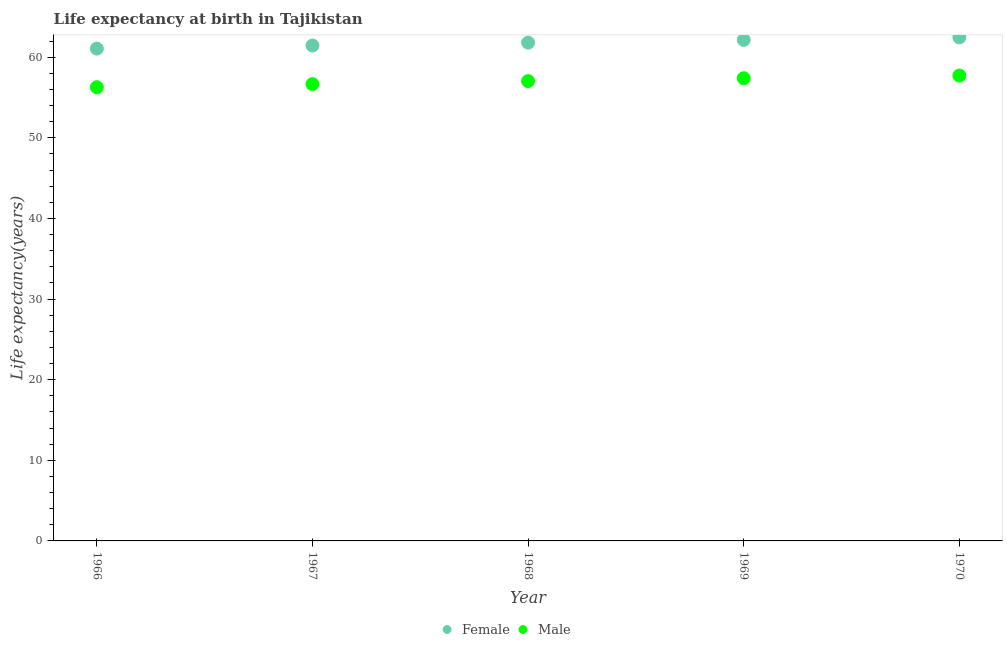Is the number of dotlines equal to the number of legend labels?
Your answer should be very brief. Yes. What is the life expectancy(male) in 1968?
Offer a terse response. 57.03. Across all years, what is the maximum life expectancy(female)?
Offer a very short reply. 62.46. Across all years, what is the minimum life expectancy(female)?
Your answer should be compact. 61.06. In which year was the life expectancy(male) minimum?
Your answer should be very brief. 1966. What is the total life expectancy(female) in the graph?
Provide a succinct answer. 308.91. What is the difference between the life expectancy(female) in 1966 and that in 1968?
Give a very brief answer. -0.74. What is the difference between the life expectancy(male) in 1969 and the life expectancy(female) in 1967?
Ensure brevity in your answer.  -4.05. What is the average life expectancy(female) per year?
Your answer should be very brief. 61.78. In the year 1968, what is the difference between the life expectancy(male) and life expectancy(female)?
Your answer should be very brief. -4.77. What is the ratio of the life expectancy(male) in 1968 to that in 1969?
Your response must be concise. 0.99. What is the difference between the highest and the second highest life expectancy(male)?
Your response must be concise. 0.33. What is the difference between the highest and the lowest life expectancy(male)?
Keep it short and to the point. 1.45. Does the graph contain grids?
Provide a short and direct response. No. How many legend labels are there?
Ensure brevity in your answer.  2. What is the title of the graph?
Ensure brevity in your answer.  Life expectancy at birth in Tajikistan. What is the label or title of the Y-axis?
Your answer should be compact. Life expectancy(years). What is the Life expectancy(years) in Female in 1966?
Your answer should be very brief. 61.06. What is the Life expectancy(years) of Male in 1966?
Your response must be concise. 56.27. What is the Life expectancy(years) of Female in 1967?
Your answer should be very brief. 61.44. What is the Life expectancy(years) in Male in 1967?
Make the answer very short. 56.66. What is the Life expectancy(years) of Female in 1968?
Offer a very short reply. 61.8. What is the Life expectancy(years) in Male in 1968?
Provide a short and direct response. 57.03. What is the Life expectancy(years) of Female in 1969?
Provide a succinct answer. 62.14. What is the Life expectancy(years) in Male in 1969?
Provide a short and direct response. 57.39. What is the Life expectancy(years) in Female in 1970?
Offer a very short reply. 62.46. What is the Life expectancy(years) of Male in 1970?
Keep it short and to the point. 57.72. Across all years, what is the maximum Life expectancy(years) of Female?
Provide a succinct answer. 62.46. Across all years, what is the maximum Life expectancy(years) of Male?
Provide a succinct answer. 57.72. Across all years, what is the minimum Life expectancy(years) of Female?
Provide a short and direct response. 61.06. Across all years, what is the minimum Life expectancy(years) in Male?
Give a very brief answer. 56.27. What is the total Life expectancy(years) in Female in the graph?
Provide a succinct answer. 308.91. What is the total Life expectancy(years) of Male in the graph?
Keep it short and to the point. 285.07. What is the difference between the Life expectancy(years) in Female in 1966 and that in 1967?
Make the answer very short. -0.38. What is the difference between the Life expectancy(years) in Male in 1966 and that in 1967?
Your response must be concise. -0.39. What is the difference between the Life expectancy(years) of Female in 1966 and that in 1968?
Your answer should be compact. -0.74. What is the difference between the Life expectancy(years) of Male in 1966 and that in 1968?
Keep it short and to the point. -0.76. What is the difference between the Life expectancy(years) of Female in 1966 and that in 1969?
Your response must be concise. -1.08. What is the difference between the Life expectancy(years) in Male in 1966 and that in 1969?
Your answer should be compact. -1.12. What is the difference between the Life expectancy(years) in Female in 1966 and that in 1970?
Offer a terse response. -1.39. What is the difference between the Life expectancy(years) in Male in 1966 and that in 1970?
Offer a terse response. -1.45. What is the difference between the Life expectancy(years) in Female in 1967 and that in 1968?
Keep it short and to the point. -0.36. What is the difference between the Life expectancy(years) in Male in 1967 and that in 1968?
Give a very brief answer. -0.37. What is the difference between the Life expectancy(years) of Male in 1967 and that in 1969?
Your answer should be very brief. -0.73. What is the difference between the Life expectancy(years) of Female in 1967 and that in 1970?
Ensure brevity in your answer.  -1.01. What is the difference between the Life expectancy(years) of Male in 1967 and that in 1970?
Offer a very short reply. -1.06. What is the difference between the Life expectancy(years) in Female in 1968 and that in 1969?
Your answer should be compact. -0.34. What is the difference between the Life expectancy(years) in Male in 1968 and that in 1969?
Make the answer very short. -0.35. What is the difference between the Life expectancy(years) in Female in 1968 and that in 1970?
Offer a very short reply. -0.65. What is the difference between the Life expectancy(years) in Male in 1968 and that in 1970?
Your response must be concise. -0.68. What is the difference between the Life expectancy(years) in Female in 1969 and that in 1970?
Keep it short and to the point. -0.31. What is the difference between the Life expectancy(years) in Male in 1969 and that in 1970?
Your answer should be very brief. -0.33. What is the difference between the Life expectancy(years) in Female in 1966 and the Life expectancy(years) in Male in 1967?
Make the answer very short. 4.4. What is the difference between the Life expectancy(years) in Female in 1966 and the Life expectancy(years) in Male in 1968?
Make the answer very short. 4.03. What is the difference between the Life expectancy(years) of Female in 1966 and the Life expectancy(years) of Male in 1969?
Provide a succinct answer. 3.68. What is the difference between the Life expectancy(years) in Female in 1966 and the Life expectancy(years) in Male in 1970?
Offer a terse response. 3.35. What is the difference between the Life expectancy(years) of Female in 1967 and the Life expectancy(years) of Male in 1968?
Your answer should be compact. 4.41. What is the difference between the Life expectancy(years) in Female in 1967 and the Life expectancy(years) in Male in 1969?
Your response must be concise. 4.05. What is the difference between the Life expectancy(years) of Female in 1967 and the Life expectancy(years) of Male in 1970?
Provide a short and direct response. 3.73. What is the difference between the Life expectancy(years) of Female in 1968 and the Life expectancy(years) of Male in 1969?
Make the answer very short. 4.42. What is the difference between the Life expectancy(years) of Female in 1968 and the Life expectancy(years) of Male in 1970?
Your answer should be compact. 4.09. What is the difference between the Life expectancy(years) in Female in 1969 and the Life expectancy(years) in Male in 1970?
Your answer should be very brief. 4.42. What is the average Life expectancy(years) in Female per year?
Ensure brevity in your answer.  61.78. What is the average Life expectancy(years) of Male per year?
Keep it short and to the point. 57.01. In the year 1966, what is the difference between the Life expectancy(years) in Female and Life expectancy(years) in Male?
Your response must be concise. 4.79. In the year 1967, what is the difference between the Life expectancy(years) in Female and Life expectancy(years) in Male?
Your answer should be compact. 4.78. In the year 1968, what is the difference between the Life expectancy(years) of Female and Life expectancy(years) of Male?
Provide a short and direct response. 4.77. In the year 1969, what is the difference between the Life expectancy(years) of Female and Life expectancy(years) of Male?
Offer a terse response. 4.75. In the year 1970, what is the difference between the Life expectancy(years) in Female and Life expectancy(years) in Male?
Provide a succinct answer. 4.74. What is the ratio of the Life expectancy(years) in Male in 1966 to that in 1967?
Offer a terse response. 0.99. What is the ratio of the Life expectancy(years) in Male in 1966 to that in 1968?
Keep it short and to the point. 0.99. What is the ratio of the Life expectancy(years) in Female in 1966 to that in 1969?
Provide a succinct answer. 0.98. What is the ratio of the Life expectancy(years) of Male in 1966 to that in 1969?
Provide a short and direct response. 0.98. What is the ratio of the Life expectancy(years) in Female in 1966 to that in 1970?
Make the answer very short. 0.98. What is the ratio of the Life expectancy(years) in Male in 1966 to that in 1970?
Offer a very short reply. 0.97. What is the ratio of the Life expectancy(years) in Male in 1967 to that in 1968?
Ensure brevity in your answer.  0.99. What is the ratio of the Life expectancy(years) in Female in 1967 to that in 1969?
Give a very brief answer. 0.99. What is the ratio of the Life expectancy(years) in Male in 1967 to that in 1969?
Ensure brevity in your answer.  0.99. What is the ratio of the Life expectancy(years) in Female in 1967 to that in 1970?
Offer a very short reply. 0.98. What is the ratio of the Life expectancy(years) of Male in 1967 to that in 1970?
Your answer should be very brief. 0.98. What is the ratio of the Life expectancy(years) in Female in 1968 to that in 1969?
Offer a terse response. 0.99. What is the ratio of the Life expectancy(years) in Male in 1968 to that in 1969?
Ensure brevity in your answer.  0.99. What is the ratio of the Life expectancy(years) in Male in 1969 to that in 1970?
Provide a succinct answer. 0.99. What is the difference between the highest and the second highest Life expectancy(years) in Female?
Your answer should be compact. 0.31. What is the difference between the highest and the second highest Life expectancy(years) of Male?
Provide a short and direct response. 0.33. What is the difference between the highest and the lowest Life expectancy(years) in Female?
Keep it short and to the point. 1.39. What is the difference between the highest and the lowest Life expectancy(years) of Male?
Your answer should be compact. 1.45. 